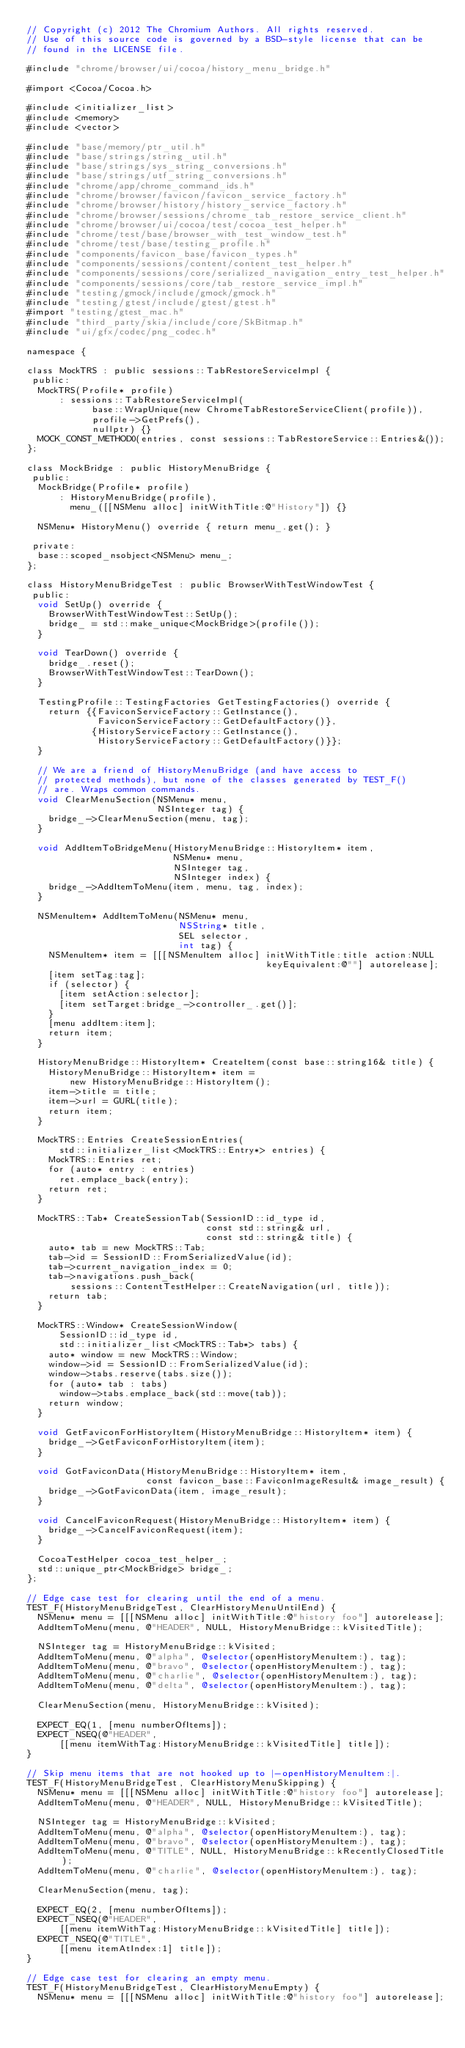<code> <loc_0><loc_0><loc_500><loc_500><_ObjectiveC_>// Copyright (c) 2012 The Chromium Authors. All rights reserved.
// Use of this source code is governed by a BSD-style license that can be
// found in the LICENSE file.

#include "chrome/browser/ui/cocoa/history_menu_bridge.h"

#import <Cocoa/Cocoa.h>

#include <initializer_list>
#include <memory>
#include <vector>

#include "base/memory/ptr_util.h"
#include "base/strings/string_util.h"
#include "base/strings/sys_string_conversions.h"
#include "base/strings/utf_string_conversions.h"
#include "chrome/app/chrome_command_ids.h"
#include "chrome/browser/favicon/favicon_service_factory.h"
#include "chrome/browser/history/history_service_factory.h"
#include "chrome/browser/sessions/chrome_tab_restore_service_client.h"
#include "chrome/browser/ui/cocoa/test/cocoa_test_helper.h"
#include "chrome/test/base/browser_with_test_window_test.h"
#include "chrome/test/base/testing_profile.h"
#include "components/favicon_base/favicon_types.h"
#include "components/sessions/content/content_test_helper.h"
#include "components/sessions/core/serialized_navigation_entry_test_helper.h"
#include "components/sessions/core/tab_restore_service_impl.h"
#include "testing/gmock/include/gmock/gmock.h"
#include "testing/gtest/include/gtest/gtest.h"
#import "testing/gtest_mac.h"
#include "third_party/skia/include/core/SkBitmap.h"
#include "ui/gfx/codec/png_codec.h"

namespace {

class MockTRS : public sessions::TabRestoreServiceImpl {
 public:
  MockTRS(Profile* profile)
      : sessions::TabRestoreServiceImpl(
            base::WrapUnique(new ChromeTabRestoreServiceClient(profile)),
            profile->GetPrefs(),
            nullptr) {}
  MOCK_CONST_METHOD0(entries, const sessions::TabRestoreService::Entries&());
};

class MockBridge : public HistoryMenuBridge {
 public:
  MockBridge(Profile* profile)
      : HistoryMenuBridge(profile),
        menu_([[NSMenu alloc] initWithTitle:@"History"]) {}

  NSMenu* HistoryMenu() override { return menu_.get(); }

 private:
  base::scoped_nsobject<NSMenu> menu_;
};

class HistoryMenuBridgeTest : public BrowserWithTestWindowTest {
 public:
  void SetUp() override {
    BrowserWithTestWindowTest::SetUp();
    bridge_ = std::make_unique<MockBridge>(profile());
  }

  void TearDown() override {
    bridge_.reset();
    BrowserWithTestWindowTest::TearDown();
  }

  TestingProfile::TestingFactories GetTestingFactories() override {
    return {{FaviconServiceFactory::GetInstance(),
             FaviconServiceFactory::GetDefaultFactory()},
            {HistoryServiceFactory::GetInstance(),
             HistoryServiceFactory::GetDefaultFactory()}};
  }

  // We are a friend of HistoryMenuBridge (and have access to
  // protected methods), but none of the classes generated by TEST_F()
  // are. Wraps common commands.
  void ClearMenuSection(NSMenu* menu,
                        NSInteger tag) {
    bridge_->ClearMenuSection(menu, tag);
  }

  void AddItemToBridgeMenu(HistoryMenuBridge::HistoryItem* item,
                           NSMenu* menu,
                           NSInteger tag,
                           NSInteger index) {
    bridge_->AddItemToMenu(item, menu, tag, index);
  }

  NSMenuItem* AddItemToMenu(NSMenu* menu,
                            NSString* title,
                            SEL selector,
                            int tag) {
    NSMenuItem* item = [[[NSMenuItem alloc] initWithTitle:title action:NULL
                                            keyEquivalent:@""] autorelease];
    [item setTag:tag];
    if (selector) {
      [item setAction:selector];
      [item setTarget:bridge_->controller_.get()];
    }
    [menu addItem:item];
    return item;
  }

  HistoryMenuBridge::HistoryItem* CreateItem(const base::string16& title) {
    HistoryMenuBridge::HistoryItem* item =
        new HistoryMenuBridge::HistoryItem();
    item->title = title;
    item->url = GURL(title);
    return item;
  }

  MockTRS::Entries CreateSessionEntries(
      std::initializer_list<MockTRS::Entry*> entries) {
    MockTRS::Entries ret;
    for (auto* entry : entries)
      ret.emplace_back(entry);
    return ret;
  }

  MockTRS::Tab* CreateSessionTab(SessionID::id_type id,
                                 const std::string& url,
                                 const std::string& title) {
    auto* tab = new MockTRS::Tab;
    tab->id = SessionID::FromSerializedValue(id);
    tab->current_navigation_index = 0;
    tab->navigations.push_back(
        sessions::ContentTestHelper::CreateNavigation(url, title));
    return tab;
  }

  MockTRS::Window* CreateSessionWindow(
      SessionID::id_type id,
      std::initializer_list<MockTRS::Tab*> tabs) {
    auto* window = new MockTRS::Window;
    window->id = SessionID::FromSerializedValue(id);
    window->tabs.reserve(tabs.size());
    for (auto* tab : tabs)
      window->tabs.emplace_back(std::move(tab));
    return window;
  }

  void GetFaviconForHistoryItem(HistoryMenuBridge::HistoryItem* item) {
    bridge_->GetFaviconForHistoryItem(item);
  }

  void GotFaviconData(HistoryMenuBridge::HistoryItem* item,
                      const favicon_base::FaviconImageResult& image_result) {
    bridge_->GotFaviconData(item, image_result);
  }

  void CancelFaviconRequest(HistoryMenuBridge::HistoryItem* item) {
    bridge_->CancelFaviconRequest(item);
  }

  CocoaTestHelper cocoa_test_helper_;
  std::unique_ptr<MockBridge> bridge_;
};

// Edge case test for clearing until the end of a menu.
TEST_F(HistoryMenuBridgeTest, ClearHistoryMenuUntilEnd) {
  NSMenu* menu = [[[NSMenu alloc] initWithTitle:@"history foo"] autorelease];
  AddItemToMenu(menu, @"HEADER", NULL, HistoryMenuBridge::kVisitedTitle);

  NSInteger tag = HistoryMenuBridge::kVisited;
  AddItemToMenu(menu, @"alpha", @selector(openHistoryMenuItem:), tag);
  AddItemToMenu(menu, @"bravo", @selector(openHistoryMenuItem:), tag);
  AddItemToMenu(menu, @"charlie", @selector(openHistoryMenuItem:), tag);
  AddItemToMenu(menu, @"delta", @selector(openHistoryMenuItem:), tag);

  ClearMenuSection(menu, HistoryMenuBridge::kVisited);

  EXPECT_EQ(1, [menu numberOfItems]);
  EXPECT_NSEQ(@"HEADER",
      [[menu itemWithTag:HistoryMenuBridge::kVisitedTitle] title]);
}

// Skip menu items that are not hooked up to |-openHistoryMenuItem:|.
TEST_F(HistoryMenuBridgeTest, ClearHistoryMenuSkipping) {
  NSMenu* menu = [[[NSMenu alloc] initWithTitle:@"history foo"] autorelease];
  AddItemToMenu(menu, @"HEADER", NULL, HistoryMenuBridge::kVisitedTitle);

  NSInteger tag = HistoryMenuBridge::kVisited;
  AddItemToMenu(menu, @"alpha", @selector(openHistoryMenuItem:), tag);
  AddItemToMenu(menu, @"bravo", @selector(openHistoryMenuItem:), tag);
  AddItemToMenu(menu, @"TITLE", NULL, HistoryMenuBridge::kRecentlyClosedTitle);
  AddItemToMenu(menu, @"charlie", @selector(openHistoryMenuItem:), tag);

  ClearMenuSection(menu, tag);

  EXPECT_EQ(2, [menu numberOfItems]);
  EXPECT_NSEQ(@"HEADER",
      [[menu itemWithTag:HistoryMenuBridge::kVisitedTitle] title]);
  EXPECT_NSEQ(@"TITLE",
      [[menu itemAtIndex:1] title]);
}

// Edge case test for clearing an empty menu.
TEST_F(HistoryMenuBridgeTest, ClearHistoryMenuEmpty) {
  NSMenu* menu = [[[NSMenu alloc] initWithTitle:@"history foo"] autorelease];</code> 